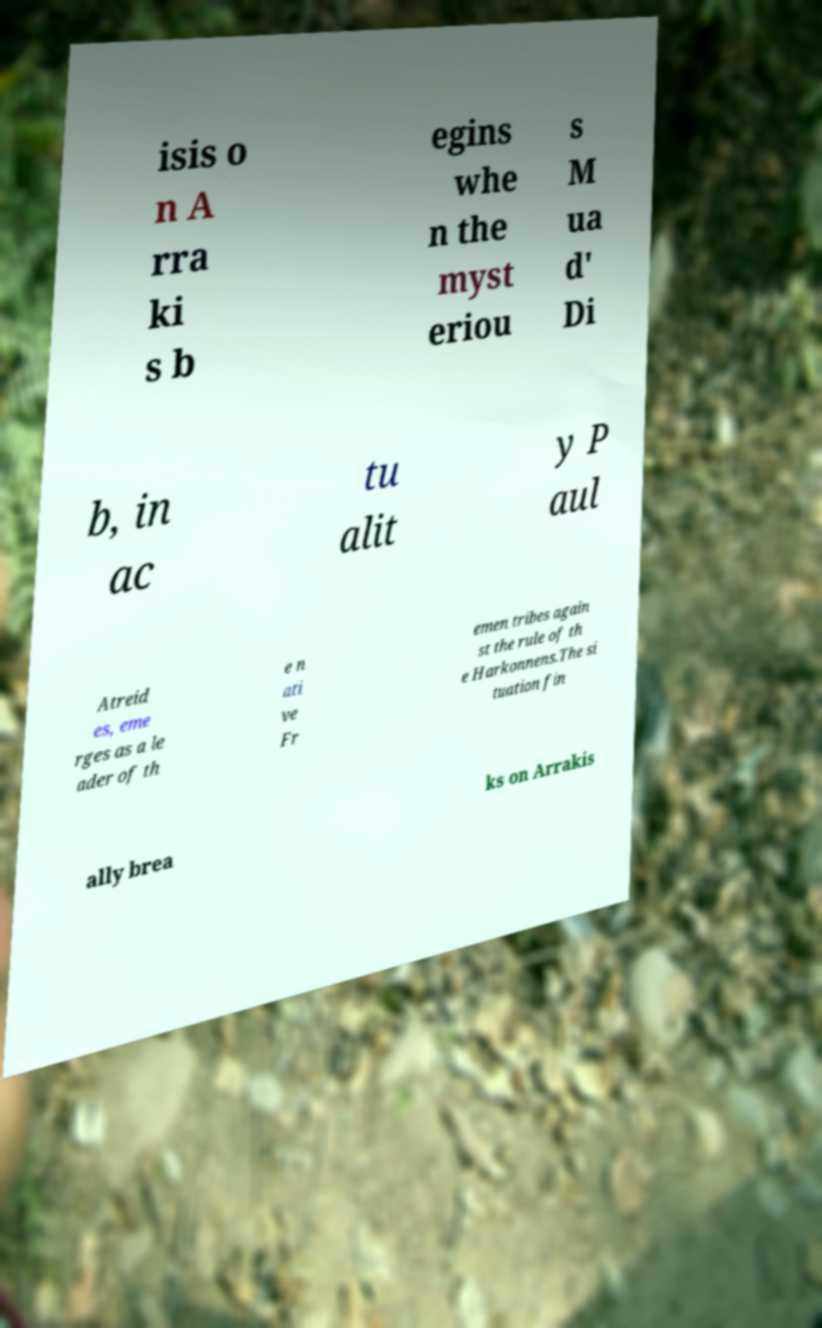Could you extract and type out the text from this image? isis o n A rra ki s b egins whe n the myst eriou s M ua d' Di b, in ac tu alit y P aul Atreid es, eme rges as a le ader of th e n ati ve Fr emen tribes again st the rule of th e Harkonnens.The si tuation fin ally brea ks on Arrakis 